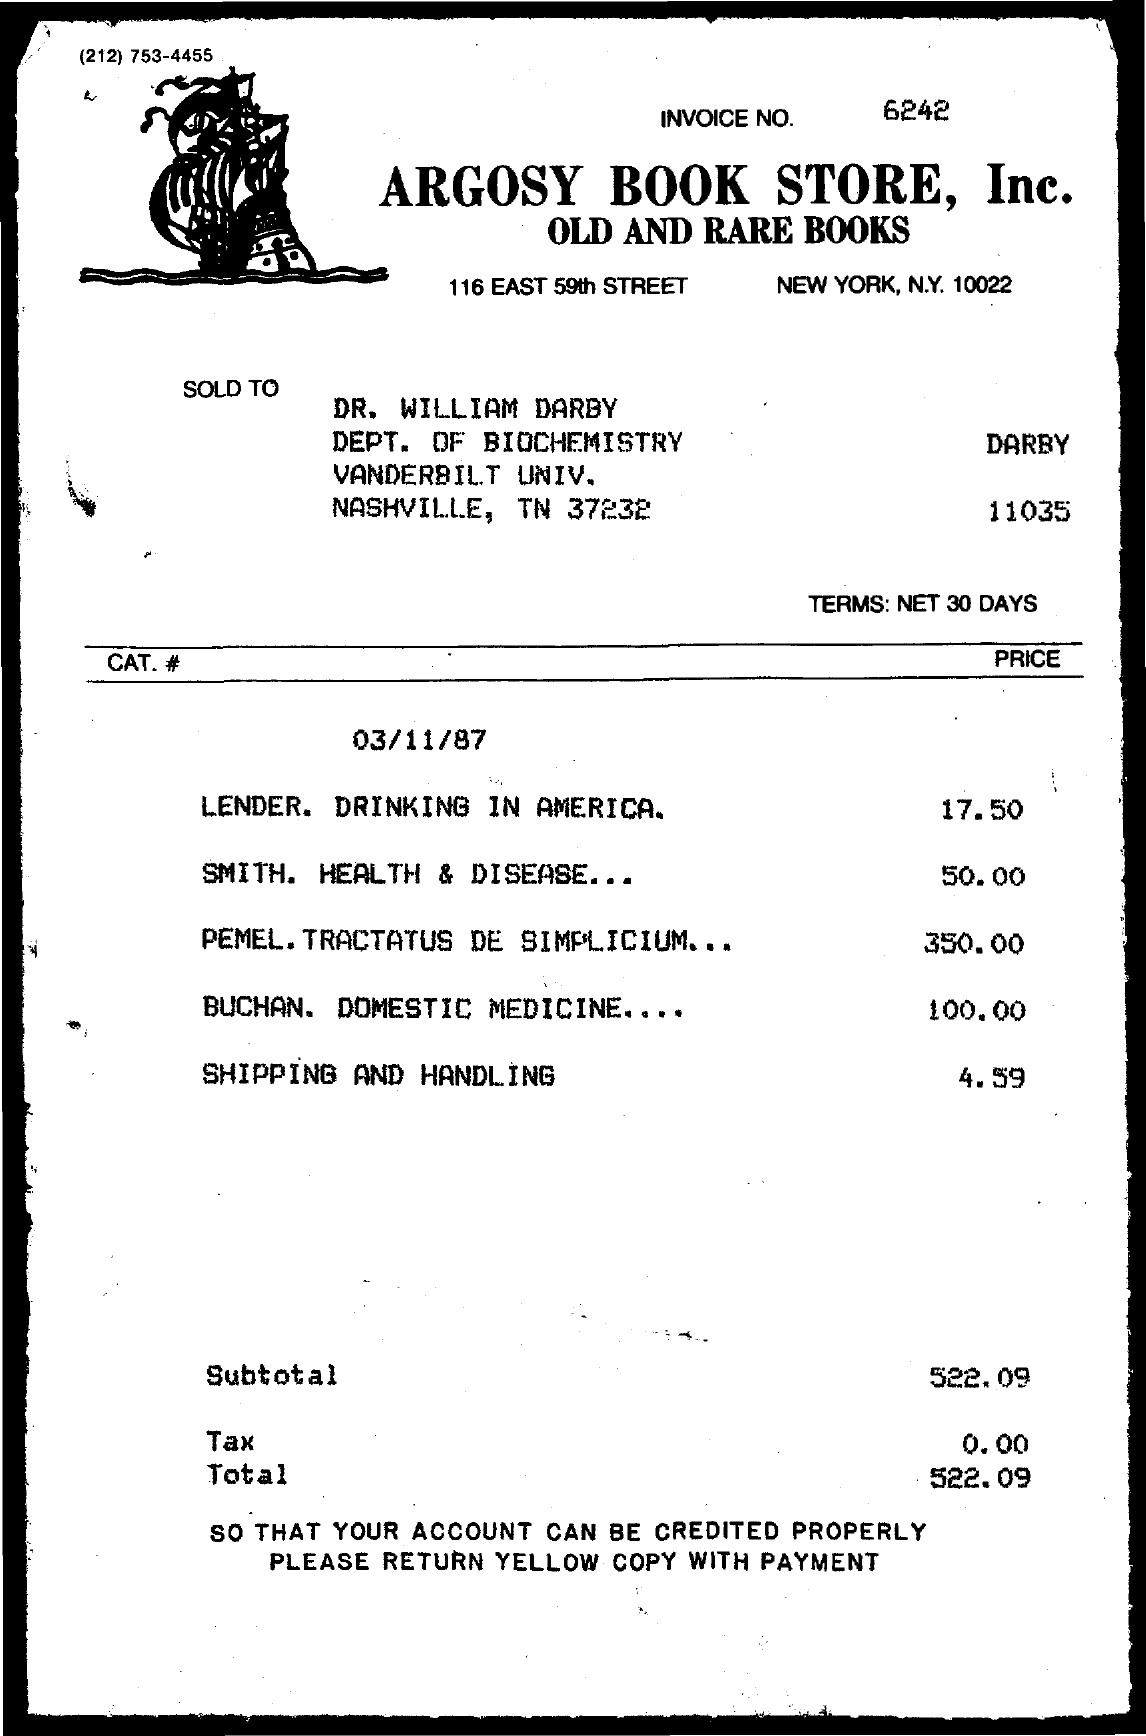Mention a couple of crucial points in this snapshot. The invoice number is 6242. The name of the book store is Argosy Book Store, Inc. The cost of Smith's Health and Disease is $50.00. Argosy Book Store, Inc. is located at 116 East 59th Street in New York, New York 10022. The subtotal is 522.09. 